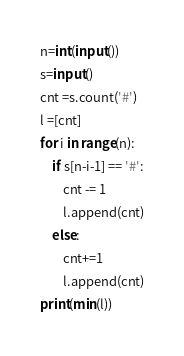Convert code to text. <code><loc_0><loc_0><loc_500><loc_500><_Python_>n=int(input())
s=input()
cnt =s.count('#')
l =[cnt]
for i in range(n):
    if s[n-i-1] == '#':
        cnt -= 1
        l.append(cnt)
    else:
        cnt+=1
        l.append(cnt)
print(min(l))</code> 